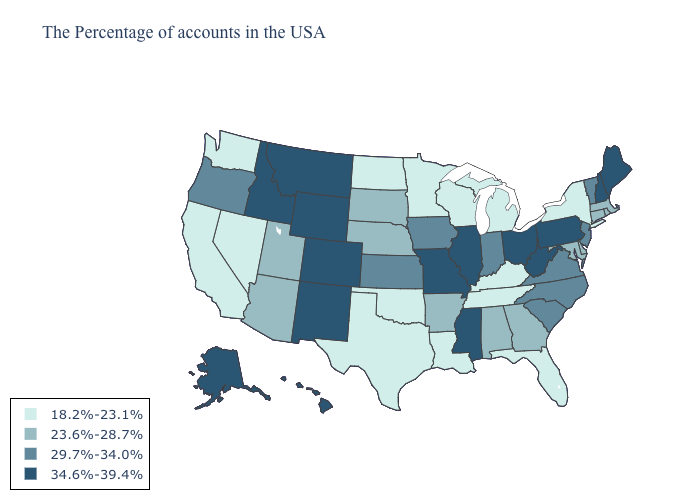Does South Carolina have the highest value in the USA?
Concise answer only. No. What is the value of Mississippi?
Short answer required. 34.6%-39.4%. Does Wisconsin have the lowest value in the USA?
Answer briefly. Yes. Does Maine have the highest value in the USA?
Give a very brief answer. Yes. Does the first symbol in the legend represent the smallest category?
Be succinct. Yes. What is the value of Iowa?
Answer briefly. 29.7%-34.0%. What is the lowest value in the USA?
Give a very brief answer. 18.2%-23.1%. Does Louisiana have a lower value than New York?
Concise answer only. No. What is the highest value in the USA?
Keep it brief. 34.6%-39.4%. Name the states that have a value in the range 29.7%-34.0%?
Be succinct. Vermont, New Jersey, Virginia, North Carolina, South Carolina, Indiana, Iowa, Kansas, Oregon. Among the states that border North Dakota , does Minnesota have the lowest value?
Quick response, please. Yes. Which states have the lowest value in the USA?
Keep it brief. New York, Florida, Michigan, Kentucky, Tennessee, Wisconsin, Louisiana, Minnesota, Oklahoma, Texas, North Dakota, Nevada, California, Washington. What is the lowest value in the West?
Answer briefly. 18.2%-23.1%. Name the states that have a value in the range 29.7%-34.0%?
Keep it brief. Vermont, New Jersey, Virginia, North Carolina, South Carolina, Indiana, Iowa, Kansas, Oregon. What is the value of Kentucky?
Quick response, please. 18.2%-23.1%. 